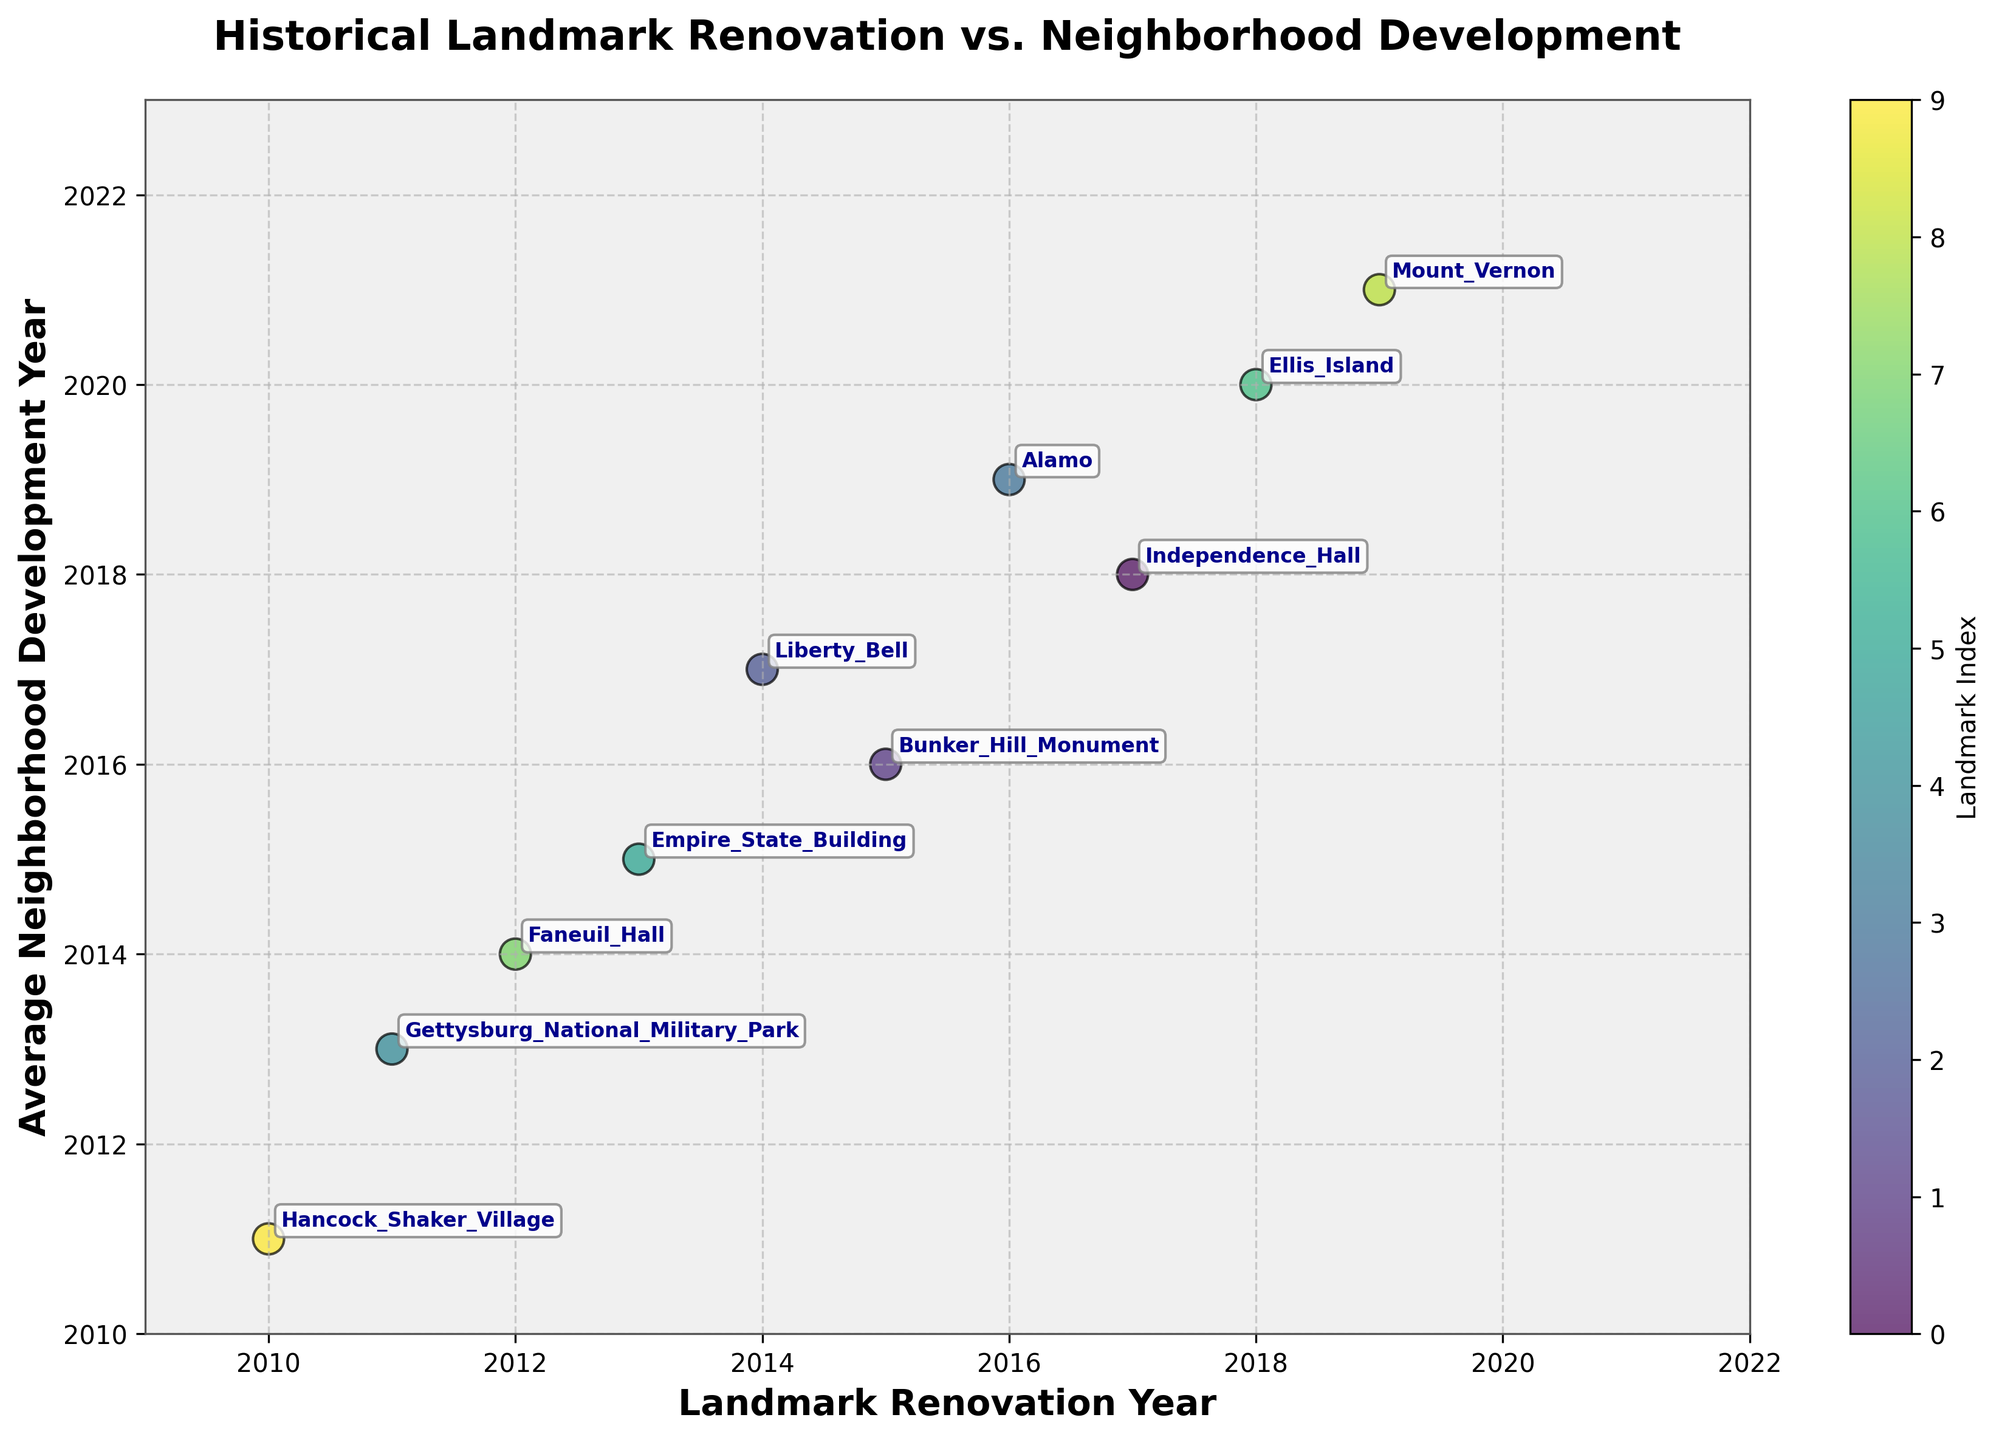What's the title of the figure? The title of a figure is usually displayed at the top center part of the plot. In this case, it reads "Historical Landmark Renovation vs. Neighborhood Development"
Answer: Historical Landmark Renovation vs. Neighborhood Development How many historical landmarks are represented in the scatter plot? Each point on the scatter plot represents a historical landmark. Counting the annotated points, there are 10 historical landmarks
Answer: 10 What are the labels of the X and Y axes? The labels for the axes are displayed near the axes themselves. The X-axis label is "Landmark Renovation Year" and the Y-axis label is "Average Neighborhood Development Year"
Answer: Landmark Renovation Year, Average Neighborhood Development Year Which historical landmark had its renovation completed in 2019? By looking at the scatter plot and observing which point is annotated with 2019 on the X-axis, we find that Mount Vernon was renovated in 2019
Answer: Mount Vernon Which landmark is represented by the point located closest to the top right corner of the plot? The top right corner represents higher values for both X and Y axes. Examining the annotations, the point closest to the top right indicates Ellis Island
Answer: Ellis Island Which neighborhood developed, on average, the earliest after the landmark’s renovation? The renovation and neighborhood development years for each landmark are given. The smallest difference between development and renovation years will indicate the answer. Hancock Shaker Village and Berkeshire County had the smallest difference (just 1 year).
Answer: Hancock Shaker Village, Berkshire County Which historical landmark and neighborhood have the largest gap between the renovation year and the neighborhood development year? Calculate the differences between the renovation years and the development years for each landmark to find the largest gap. The Alamo (2016) and Downtown San Antonio (2019) show a gap of 3 years, the largest in the dataset
Answer: Alamo, Downtown San Antonio Is there any landmark that was renovated in the same year its neighborhood was developed? By comparing the X and Y axis values, none of the historical landmarks have the same renovation and development year
Answer: No What is the average renovation year for the landmarks in the dataset? Add all renovation years and divide by the number of landmarks: (2017+2015+2014+2016+2011+2013+2018+2012+2019+2010) / 10 = 2015.5
Answer: 2015.5 Compare Independence Hall and Empire State Building in terms of neighborhood development year. Which developed earlier? Comparing the Y-axis values for these landmarks, Independence Hall's neighborhood development year is 2018, and the Empire State Building's is 2015. Thus, Empire State Building developed earlier
Answer: Empire State Building 